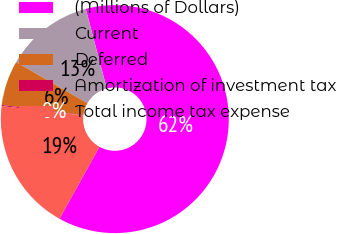<chart> <loc_0><loc_0><loc_500><loc_500><pie_chart><fcel>(Millions of Dollars)<fcel>Current<fcel>Deferred<fcel>Amortization of investment tax<fcel>Total income tax expense<nl><fcel>62.17%<fcel>12.56%<fcel>6.36%<fcel>0.15%<fcel>18.76%<nl></chart> 